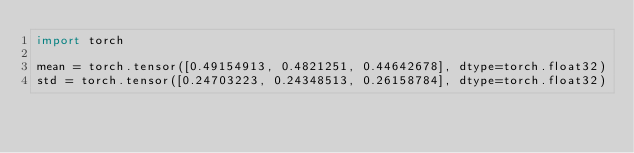<code> <loc_0><loc_0><loc_500><loc_500><_Python_>import torch

mean = torch.tensor([0.49154913, 0.4821251, 0.44642678], dtype=torch.float32)
std = torch.tensor([0.24703223, 0.24348513, 0.26158784], dtype=torch.float32)</code> 